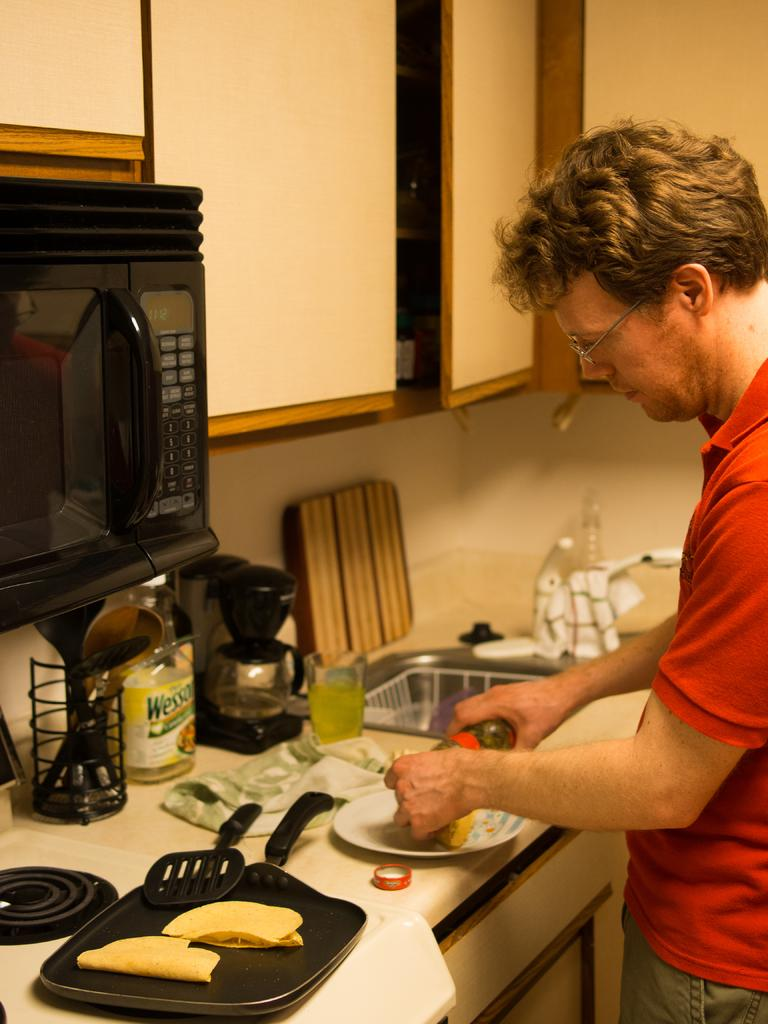Provide a one-sentence caption for the provided image. A man prepares food in his kitchen and there is a bottle of Wesson oil on the counter. 